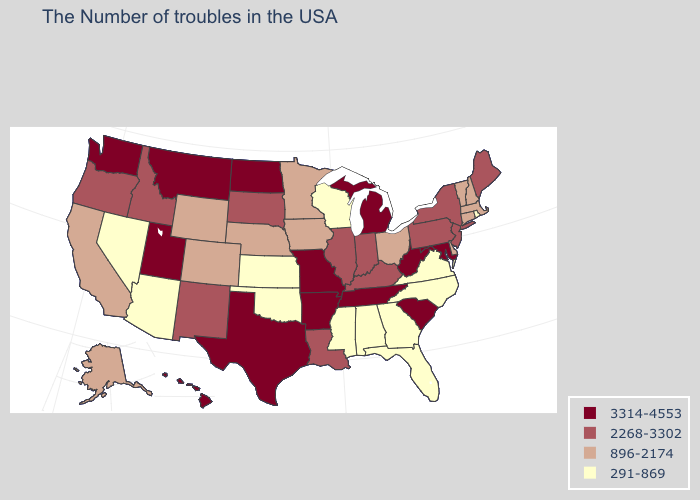Which states have the highest value in the USA?
Quick response, please. Maryland, South Carolina, West Virginia, Michigan, Tennessee, Missouri, Arkansas, Texas, North Dakota, Utah, Montana, Washington, Hawaii. What is the highest value in states that border Texas?
Quick response, please. 3314-4553. Does the map have missing data?
Write a very short answer. No. Does California have a higher value than Nevada?
Quick response, please. Yes. How many symbols are there in the legend?
Be succinct. 4. Name the states that have a value in the range 3314-4553?
Write a very short answer. Maryland, South Carolina, West Virginia, Michigan, Tennessee, Missouri, Arkansas, Texas, North Dakota, Utah, Montana, Washington, Hawaii. What is the lowest value in states that border Virginia?
Be succinct. 291-869. Does the map have missing data?
Quick response, please. No. Name the states that have a value in the range 2268-3302?
Concise answer only. Maine, New York, New Jersey, Pennsylvania, Kentucky, Indiana, Illinois, Louisiana, South Dakota, New Mexico, Idaho, Oregon. Which states have the highest value in the USA?
Give a very brief answer. Maryland, South Carolina, West Virginia, Michigan, Tennessee, Missouri, Arkansas, Texas, North Dakota, Utah, Montana, Washington, Hawaii. What is the lowest value in states that border Pennsylvania?
Concise answer only. 896-2174. Among the states that border New Hampshire , which have the lowest value?
Quick response, please. Massachusetts, Vermont. Does Washington have the highest value in the West?
Concise answer only. Yes. Name the states that have a value in the range 896-2174?
Write a very short answer. Massachusetts, New Hampshire, Vermont, Connecticut, Delaware, Ohio, Minnesota, Iowa, Nebraska, Wyoming, Colorado, California, Alaska. 